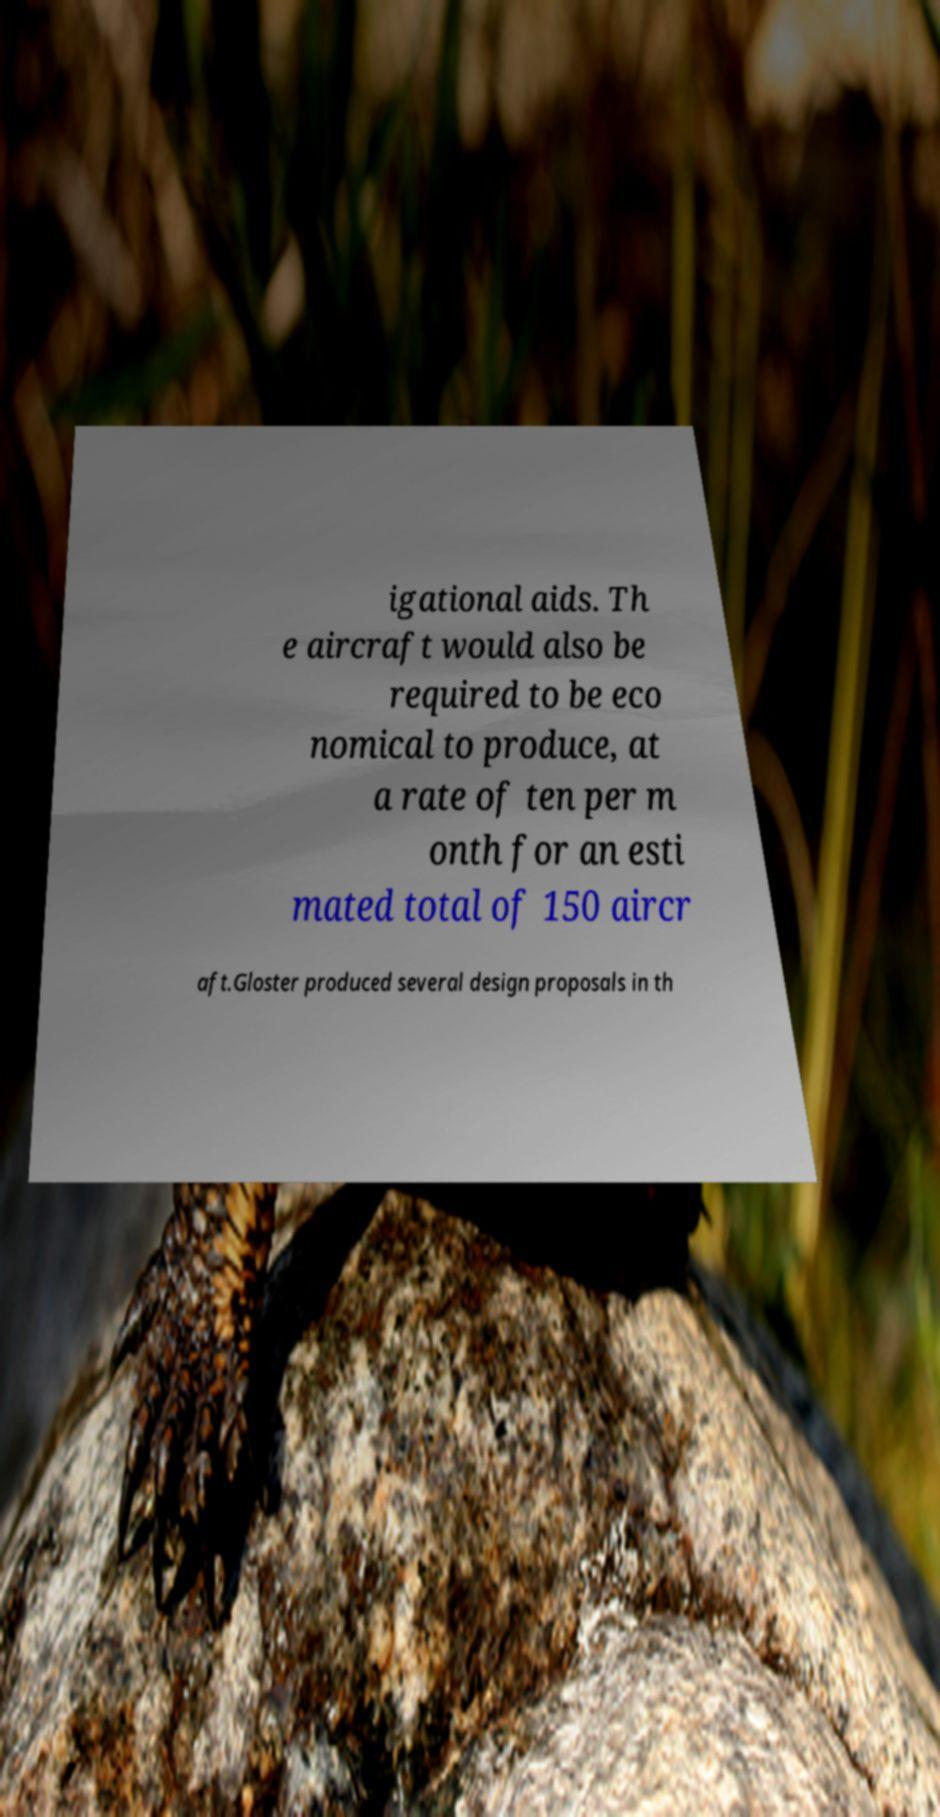For documentation purposes, I need the text within this image transcribed. Could you provide that? igational aids. Th e aircraft would also be required to be eco nomical to produce, at a rate of ten per m onth for an esti mated total of 150 aircr aft.Gloster produced several design proposals in th 